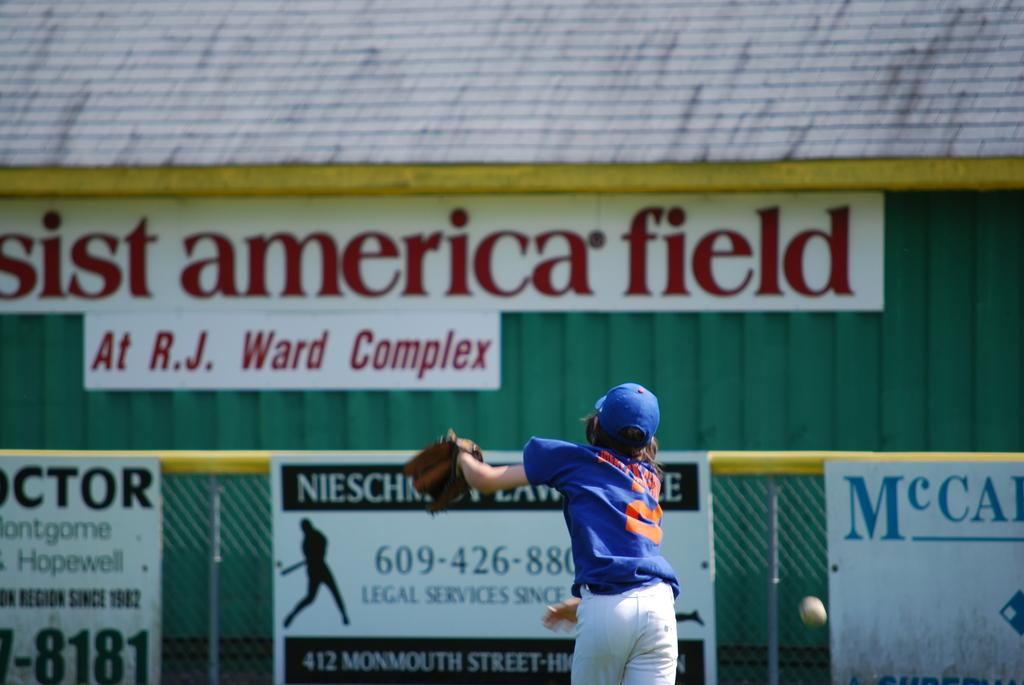<image>
Relay a brief, clear account of the picture shown. A baseball player in front of a sign reading R.J. Ward Complex. 